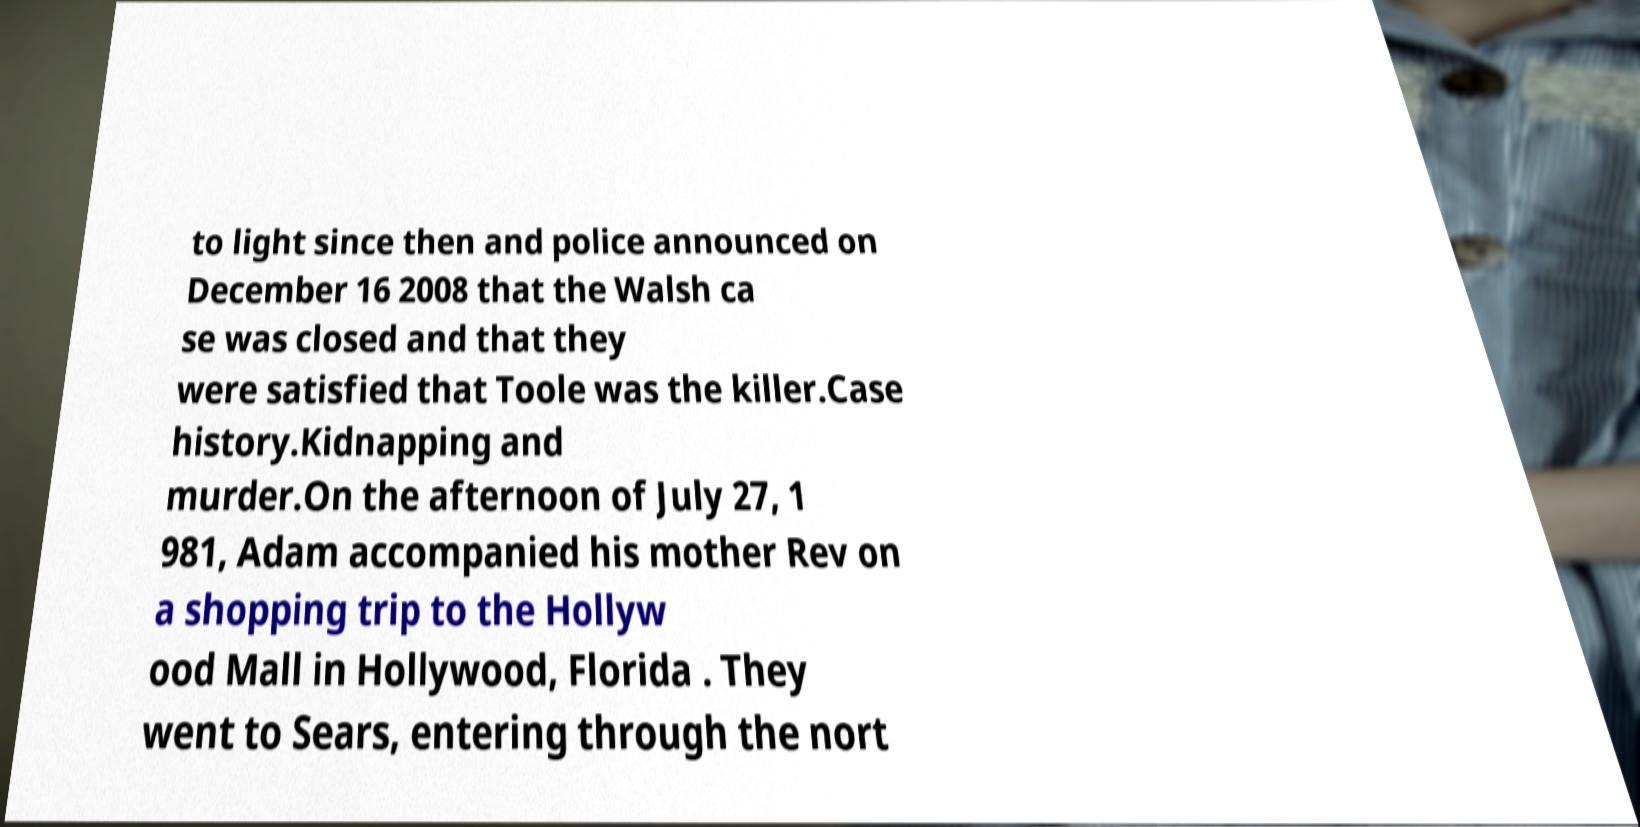Can you read and provide the text displayed in the image?This photo seems to have some interesting text. Can you extract and type it out for me? to light since then and police announced on December 16 2008 that the Walsh ca se was closed and that they were satisfied that Toole was the killer.Case history.Kidnapping and murder.On the afternoon of July 27, 1 981, Adam accompanied his mother Rev on a shopping trip to the Hollyw ood Mall in Hollywood, Florida . They went to Sears, entering through the nort 